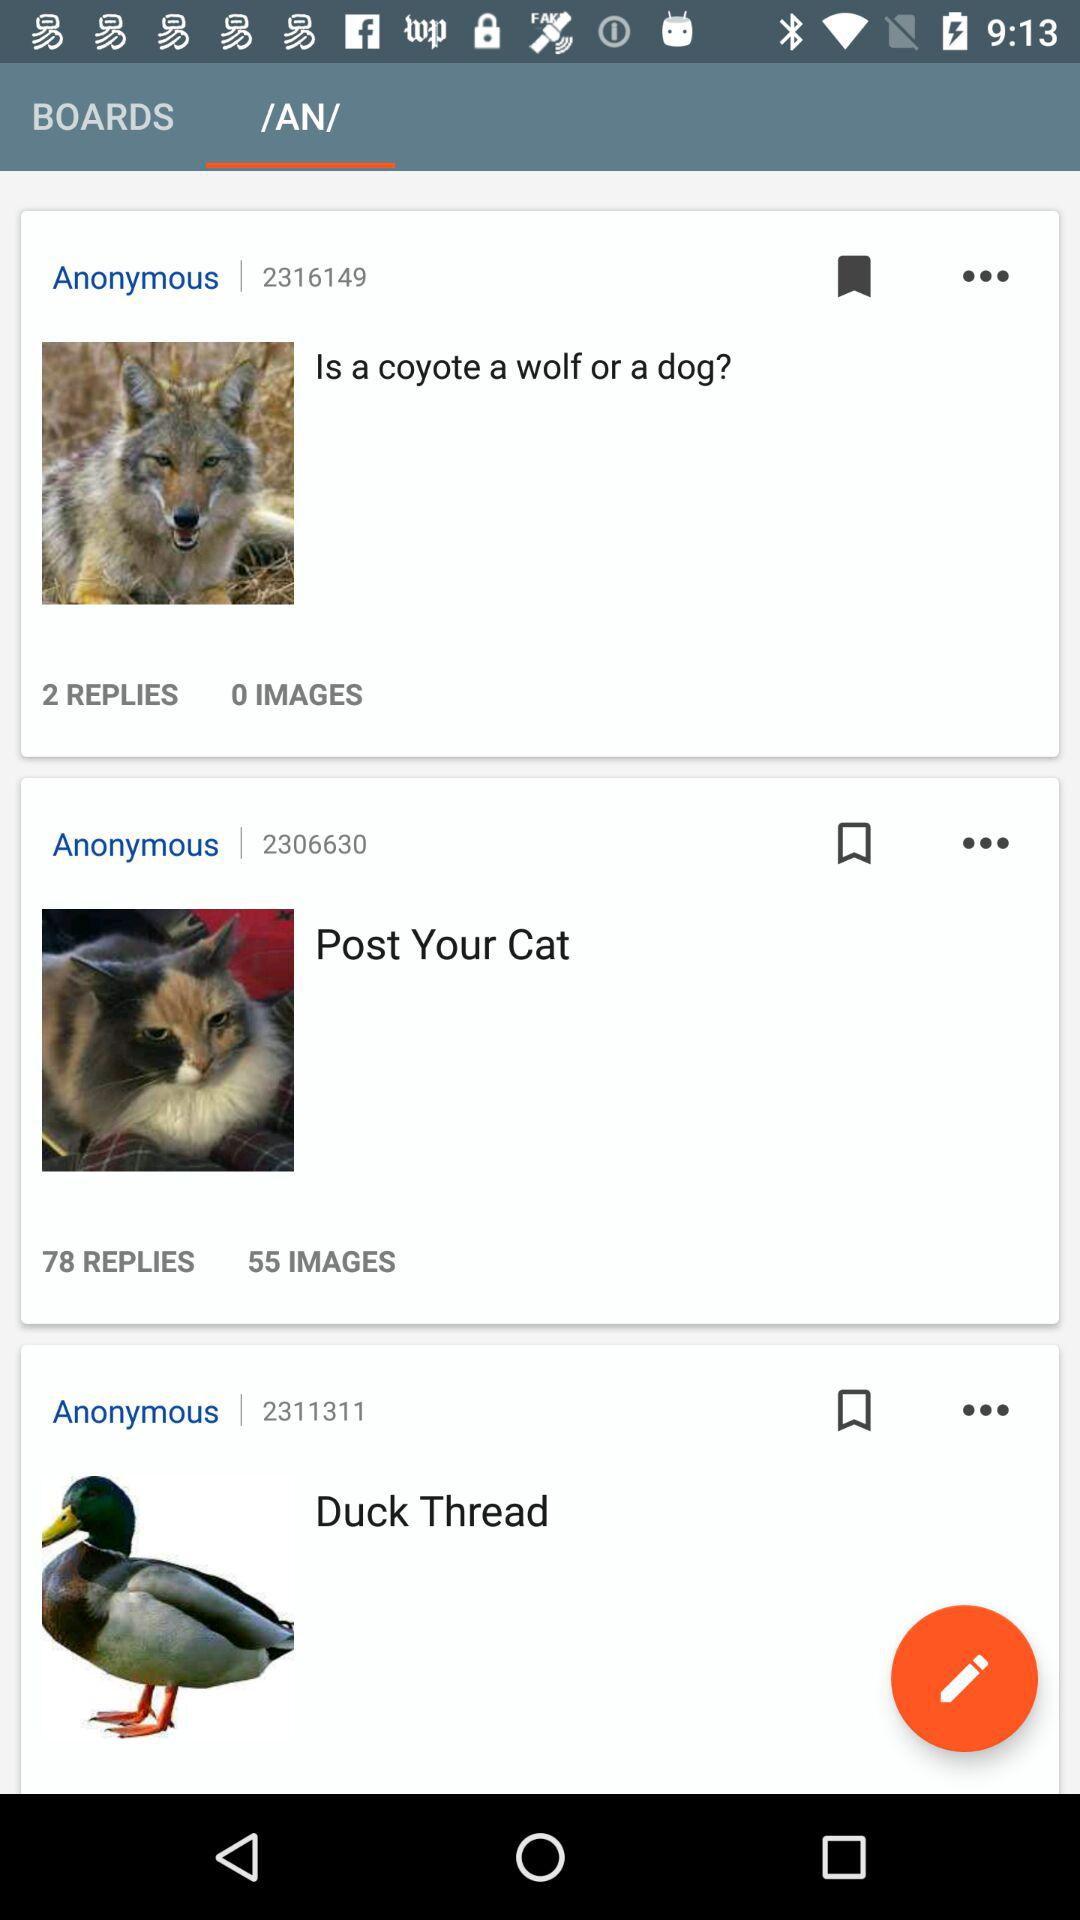What is the total number of replies for "Is a coyote a wolf or a dog?"? The total number of replies for "Is a coyote a wolf or a dog?" is 2. 